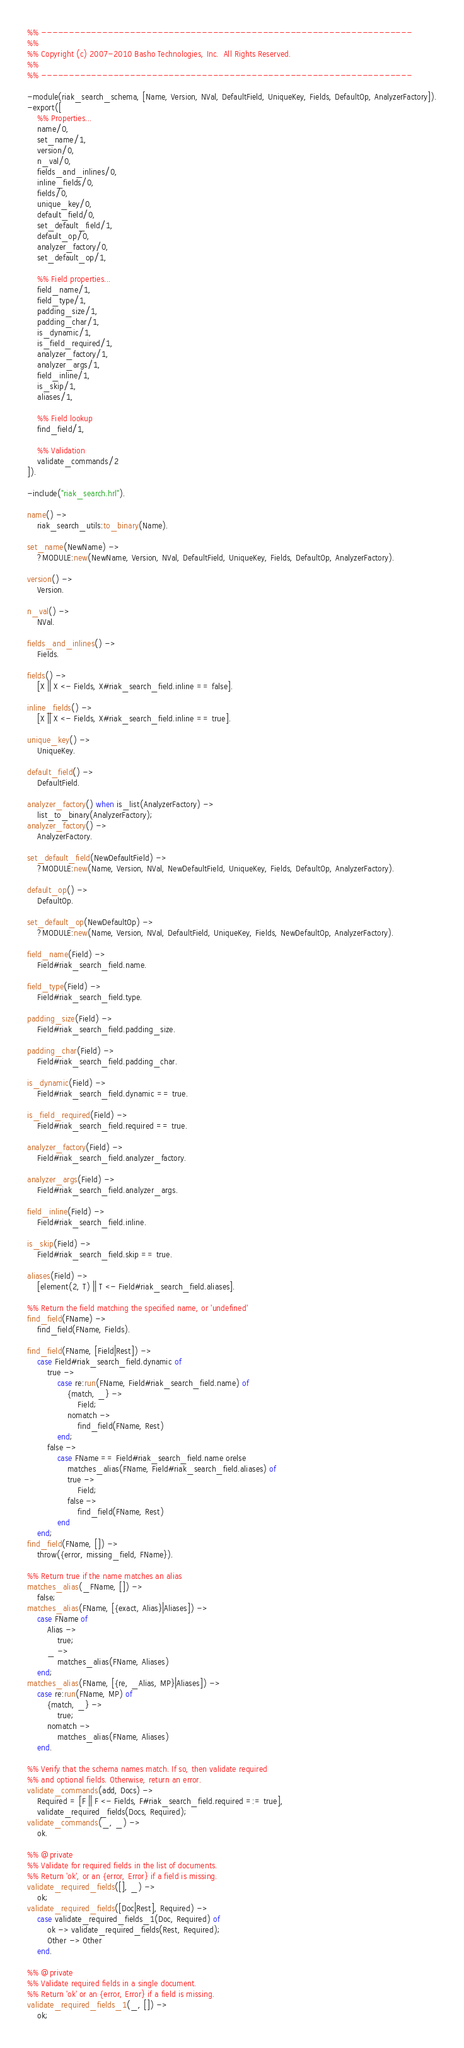<code> <loc_0><loc_0><loc_500><loc_500><_Erlang_>%% -------------------------------------------------------------------
%%
%% Copyright (c) 2007-2010 Basho Technologies, Inc.  All Rights Reserved.
%%
%% -------------------------------------------------------------------

-module(riak_search_schema, [Name, Version, NVal, DefaultField, UniqueKey, Fields, DefaultOp, AnalyzerFactory]).
-export([
    %% Properties...
    name/0,
    set_name/1,
    version/0,
    n_val/0,
    fields_and_inlines/0,
    inline_fields/0,
    fields/0,
    unique_key/0,
    default_field/0,
    set_default_field/1,
    default_op/0,
    analyzer_factory/0,
    set_default_op/1,

    %% Field properties...
    field_name/1,
    field_type/1,
    padding_size/1,
    padding_char/1,
    is_dynamic/1,
    is_field_required/1,
    analyzer_factory/1,
    analyzer_args/1,
    field_inline/1,
    is_skip/1,
    aliases/1,

    %% Field lookup
    find_field/1,

    %% Validation
    validate_commands/2
]).

-include("riak_search.hrl").

name() ->
    riak_search_utils:to_binary(Name).

set_name(NewName) ->
    ?MODULE:new(NewName, Version, NVal, DefaultField, UniqueKey, Fields, DefaultOp, AnalyzerFactory).

version() ->
    Version.

n_val() ->
    NVal.

fields_and_inlines() ->
    Fields.

fields() ->
    [X || X <- Fields, X#riak_search_field.inline == false].

inline_fields() ->
    [X || X <- Fields, X#riak_search_field.inline == true].

unique_key() ->
    UniqueKey.

default_field() ->
    DefaultField.

analyzer_factory() when is_list(AnalyzerFactory) ->
    list_to_binary(AnalyzerFactory);
analyzer_factory() ->
    AnalyzerFactory.

set_default_field(NewDefaultField) ->
    ?MODULE:new(Name, Version, NVal, NewDefaultField, UniqueKey, Fields, DefaultOp, AnalyzerFactory).

default_op() ->
    DefaultOp.

set_default_op(NewDefaultOp) ->
    ?MODULE:new(Name, Version, NVal, DefaultField, UniqueKey, Fields, NewDefaultOp, AnalyzerFactory).

field_name(Field) ->
    Field#riak_search_field.name.

field_type(Field) ->
    Field#riak_search_field.type.

padding_size(Field) ->
    Field#riak_search_field.padding_size.

padding_char(Field) ->
    Field#riak_search_field.padding_char.

is_dynamic(Field) ->
    Field#riak_search_field.dynamic == true.

is_field_required(Field) ->
    Field#riak_search_field.required == true.

analyzer_factory(Field) ->
    Field#riak_search_field.analyzer_factory.

analyzer_args(Field) ->
    Field#riak_search_field.analyzer_args.

field_inline(Field) ->
    Field#riak_search_field.inline.

is_skip(Field) ->
    Field#riak_search_field.skip == true.

aliases(Field) ->
    [element(2, T) || T <- Field#riak_search_field.aliases].

%% Return the field matching the specified name, or 'undefined'
find_field(FName) ->
    find_field(FName, Fields).

find_field(FName, [Field|Rest]) ->
    case Field#riak_search_field.dynamic of
        true ->
            case re:run(FName, Field#riak_search_field.name) of
                {match, _} ->
                    Field;
                nomatch ->
                    find_field(FName, Rest)
            end;
        false ->
            case FName == Field#riak_search_field.name orelse 
                matches_alias(FName, Field#riak_search_field.aliases) of
                true ->
                    Field;
                false ->                 
                    find_field(FName, Rest)
            end
    end;
find_field(FName, []) ->
    throw({error, missing_field, FName}).

%% Return true if the name matches an alias
matches_alias(_FName, []) ->
    false;
matches_alias(FName, [{exact, Alias}|Aliases]) ->
    case FName of
        Alias ->
            true;
        _ ->
            matches_alias(FName, Aliases)
    end;
matches_alias(FName, [{re, _Alias, MP}|Aliases]) ->
    case re:run(FName, MP) of
        {match, _} ->
            true;
        nomatch ->
            matches_alias(FName, Aliases)
    end.

%% Verify that the schema names match. If so, then validate required
%% and optional fields. Otherwise, return an error.
validate_commands(add, Docs) ->
    Required = [F || F <- Fields, F#riak_search_field.required =:= true],
    validate_required_fields(Docs, Required);
validate_commands(_, _) ->
    ok.

%% @private
%% Validate for required fields in the list of documents.
%% Return 'ok', or an {error, Error} if a field is missing.
validate_required_fields([], _) ->
    ok;
validate_required_fields([Doc|Rest], Required) ->
    case validate_required_fields_1(Doc, Required) of
        ok -> validate_required_fields(Rest, Required);
        Other -> Other
    end.

%% @private
%% Validate required fields in a single document.
%% Return 'ok' or an {error, Error} if a field is missing.
validate_required_fields_1(_, []) ->
    ok;</code> 